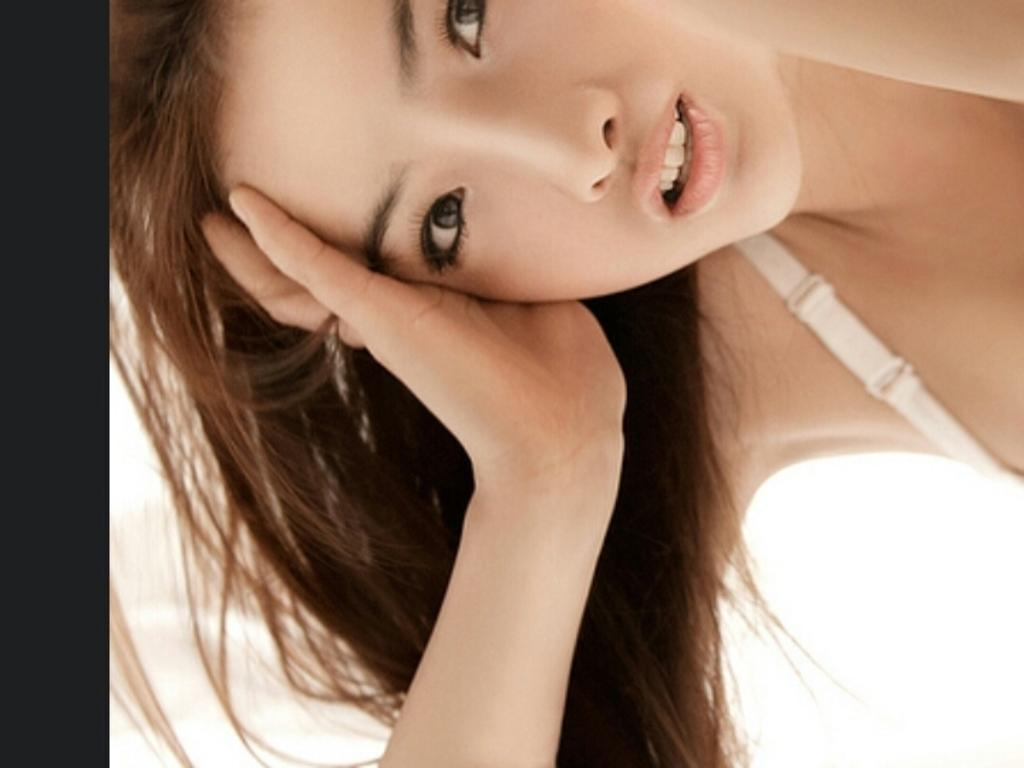Who is the main subject in the image? There is a girl in the image. What color is the background of the image? The background of the image is white. What type of crime is being committed in the image? There is no crime being committed in the image; it features a girl in a white background. What form does the girl take in the image? The girl is depicted in a two-dimensional image, not a physical form. 